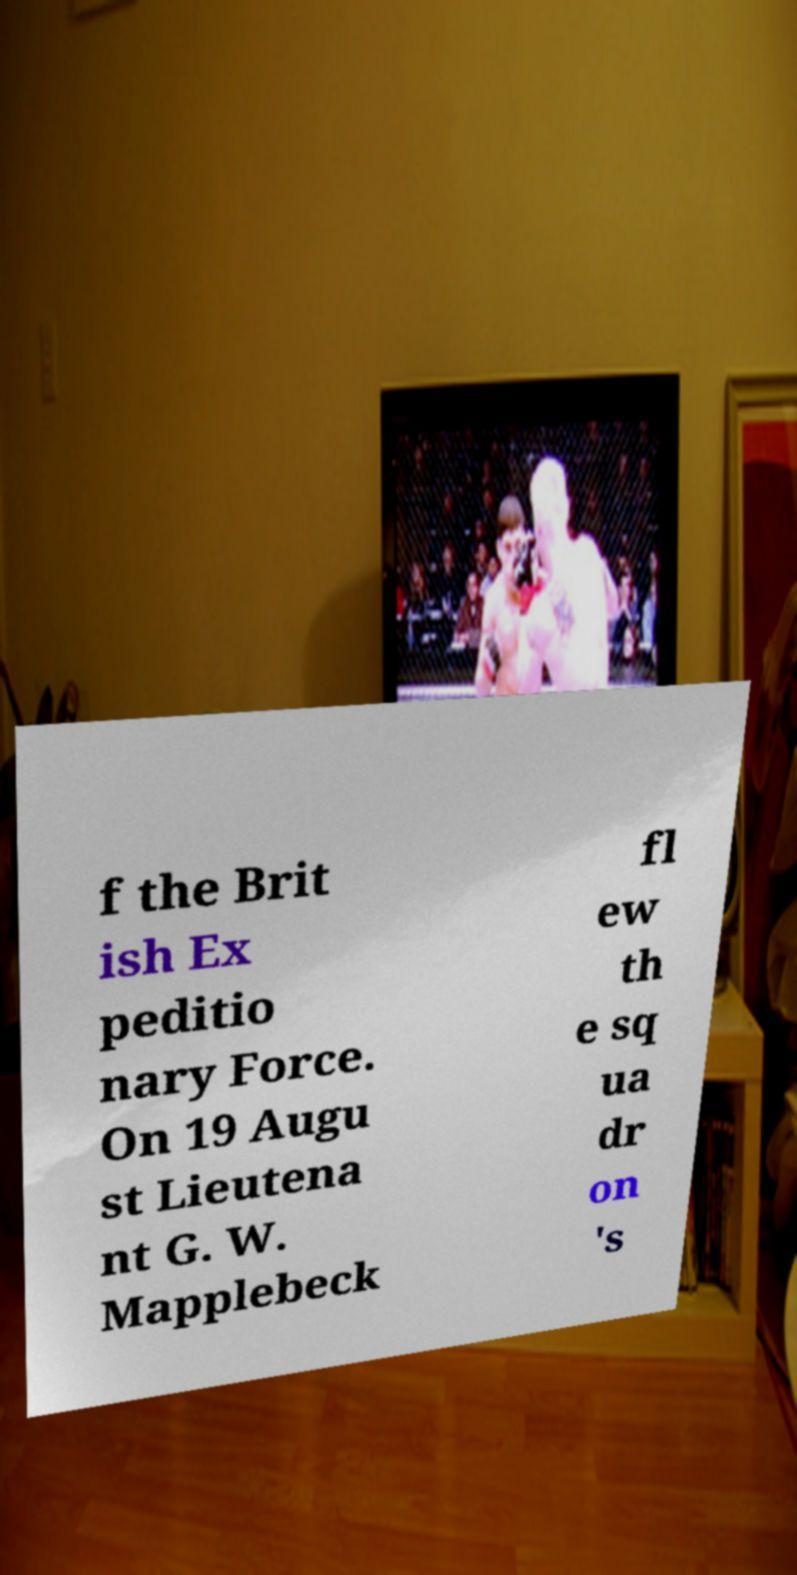I need the written content from this picture converted into text. Can you do that? f the Brit ish Ex peditio nary Force. On 19 Augu st Lieutena nt G. W. Mapplebeck fl ew th e sq ua dr on 's 